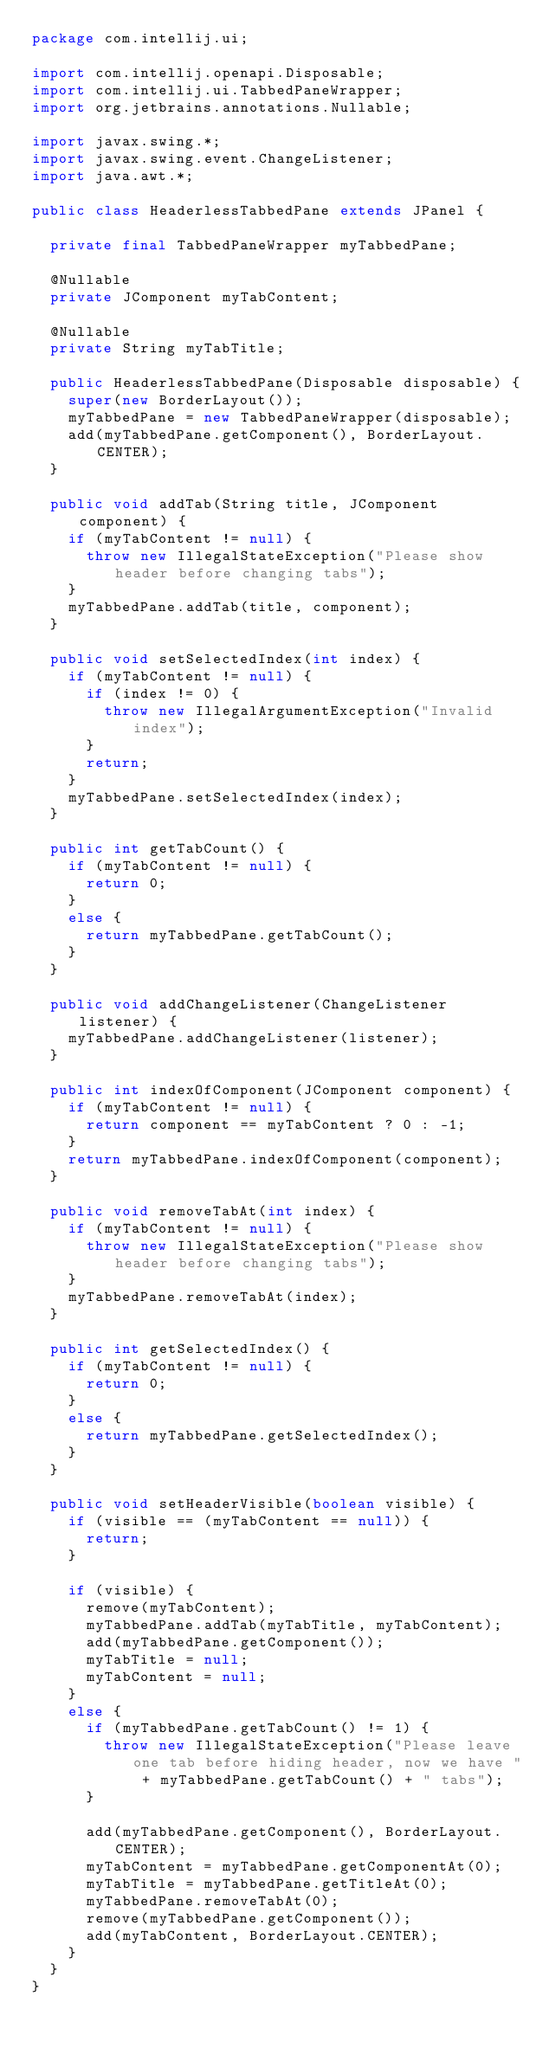Convert code to text. <code><loc_0><loc_0><loc_500><loc_500><_Java_>package com.intellij.ui;

import com.intellij.openapi.Disposable;
import com.intellij.ui.TabbedPaneWrapper;
import org.jetbrains.annotations.Nullable;

import javax.swing.*;
import javax.swing.event.ChangeListener;
import java.awt.*;

public class HeaderlessTabbedPane extends JPanel {

  private final TabbedPaneWrapper myTabbedPane;

  @Nullable
  private JComponent myTabContent;

  @Nullable
  private String myTabTitle;

  public HeaderlessTabbedPane(Disposable disposable) {
    super(new BorderLayout());
    myTabbedPane = new TabbedPaneWrapper(disposable);
    add(myTabbedPane.getComponent(), BorderLayout.CENTER);
  }

  public void addTab(String title, JComponent component) {
    if (myTabContent != null) {
      throw new IllegalStateException("Please show header before changing tabs");
    }
    myTabbedPane.addTab(title, component);
  }

  public void setSelectedIndex(int index) {
    if (myTabContent != null) {
      if (index != 0) {
        throw new IllegalArgumentException("Invalid index");
      }
      return;
    }
    myTabbedPane.setSelectedIndex(index);
  }

  public int getTabCount() {
    if (myTabContent != null) {
      return 0;
    }
    else {
      return myTabbedPane.getTabCount();
    }
  }

  public void addChangeListener(ChangeListener listener) {
    myTabbedPane.addChangeListener(listener);
  }

  public int indexOfComponent(JComponent component) {
    if (myTabContent != null) {
      return component == myTabContent ? 0 : -1;
    }
    return myTabbedPane.indexOfComponent(component);
  }

  public void removeTabAt(int index) {
    if (myTabContent != null) {
      throw new IllegalStateException("Please show header before changing tabs");
    }
    myTabbedPane.removeTabAt(index);
  }

  public int getSelectedIndex() {
    if (myTabContent != null) {
      return 0;
    }
    else {
      return myTabbedPane.getSelectedIndex();
    }
  }

  public void setHeaderVisible(boolean visible) {
    if (visible == (myTabContent == null)) {
      return;
    }

    if (visible) {
      remove(myTabContent);
      myTabbedPane.addTab(myTabTitle, myTabContent);
      add(myTabbedPane.getComponent());
      myTabTitle = null;
      myTabContent = null;
    }
    else {
      if (myTabbedPane.getTabCount() != 1) {
        throw new IllegalStateException("Please leave one tab before hiding header, now we have " + myTabbedPane.getTabCount() + " tabs");
      }

      add(myTabbedPane.getComponent(), BorderLayout.CENTER);
      myTabContent = myTabbedPane.getComponentAt(0);
      myTabTitle = myTabbedPane.getTitleAt(0);
      myTabbedPane.removeTabAt(0);
      remove(myTabbedPane.getComponent());
      add(myTabContent, BorderLayout.CENTER);
    }
  }
}
</code> 